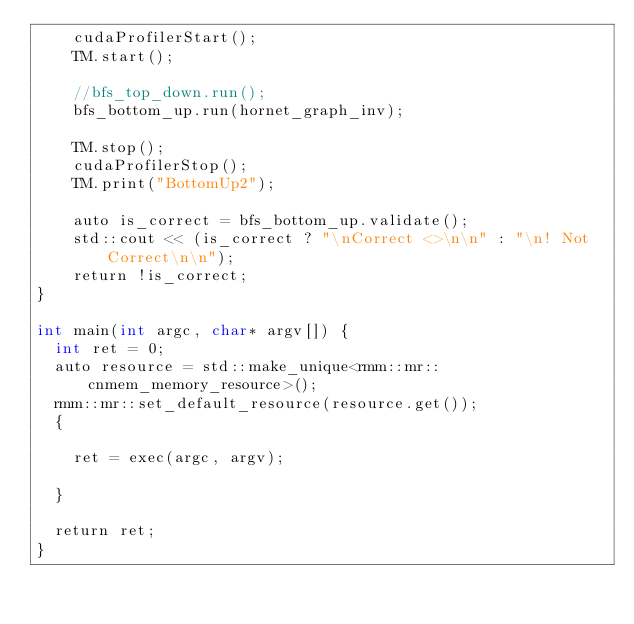Convert code to text. <code><loc_0><loc_0><loc_500><loc_500><_Cuda_>    cudaProfilerStart();
    TM.start();

    //bfs_top_down.run();
    bfs_bottom_up.run(hornet_graph_inv);

    TM.stop();
    cudaProfilerStop();
    TM.print("BottomUp2");

    auto is_correct = bfs_bottom_up.validate();
    std::cout << (is_correct ? "\nCorrect <>\n\n" : "\n! Not Correct\n\n");
    return !is_correct;
}

int main(int argc, char* argv[]) {
  int ret = 0;
  auto resource = std::make_unique<rmm::mr::cnmem_memory_resource>();
  rmm::mr::set_default_resource(resource.get());
  {

    ret = exec(argc, argv);

  }

  return ret;
}

</code> 